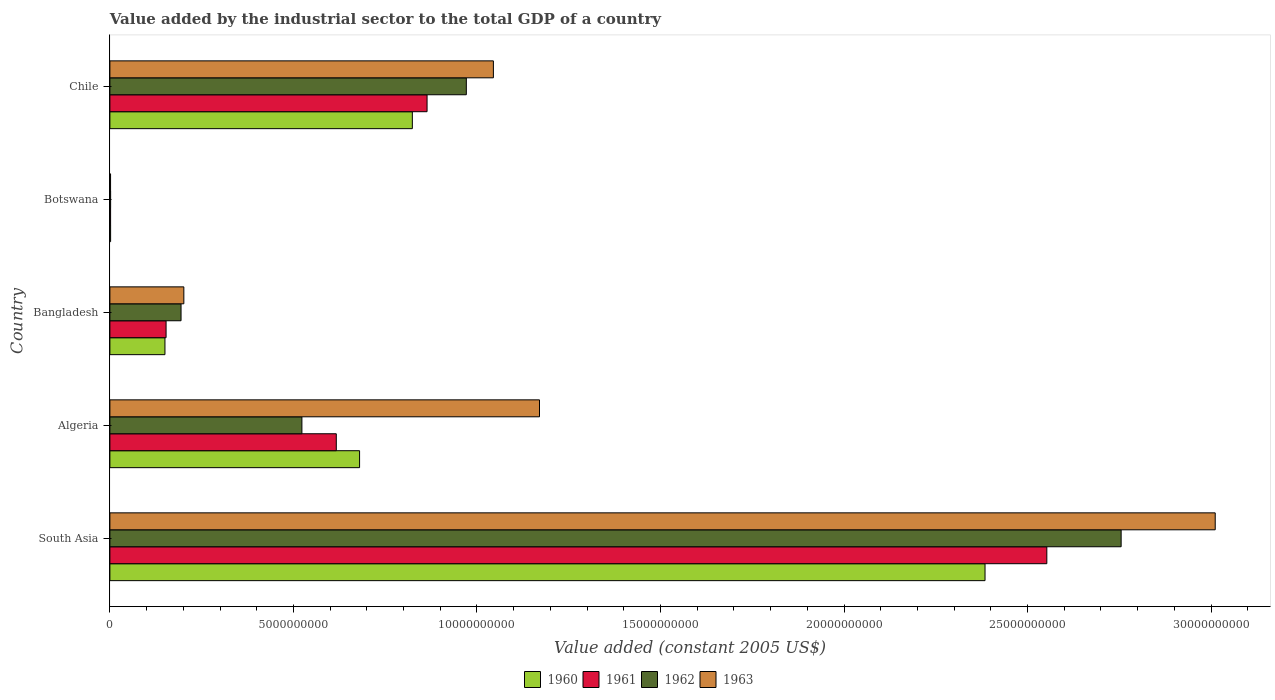How many bars are there on the 1st tick from the bottom?
Offer a terse response. 4. What is the label of the 2nd group of bars from the top?
Offer a very short reply. Botswana. What is the value added by the industrial sector in 1961 in Chile?
Make the answer very short. 8.64e+09. Across all countries, what is the maximum value added by the industrial sector in 1963?
Give a very brief answer. 3.01e+1. Across all countries, what is the minimum value added by the industrial sector in 1961?
Ensure brevity in your answer.  1.92e+07. In which country was the value added by the industrial sector in 1960 minimum?
Your answer should be compact. Botswana. What is the total value added by the industrial sector in 1960 in the graph?
Your answer should be compact. 4.04e+1. What is the difference between the value added by the industrial sector in 1962 in Algeria and that in Botswana?
Your answer should be compact. 5.21e+09. What is the difference between the value added by the industrial sector in 1962 in Chile and the value added by the industrial sector in 1961 in Algeria?
Offer a terse response. 3.54e+09. What is the average value added by the industrial sector in 1963 per country?
Offer a very short reply. 1.09e+1. What is the difference between the value added by the industrial sector in 1961 and value added by the industrial sector in 1963 in Bangladesh?
Give a very brief answer. -4.84e+08. In how many countries, is the value added by the industrial sector in 1963 greater than 1000000000 US$?
Give a very brief answer. 4. What is the ratio of the value added by the industrial sector in 1961 in Algeria to that in Botswana?
Give a very brief answer. 321.41. Is the difference between the value added by the industrial sector in 1961 in Algeria and Bangladesh greater than the difference between the value added by the industrial sector in 1963 in Algeria and Bangladesh?
Your answer should be very brief. No. What is the difference between the highest and the second highest value added by the industrial sector in 1963?
Offer a very short reply. 1.84e+1. What is the difference between the highest and the lowest value added by the industrial sector in 1962?
Make the answer very short. 2.75e+1. Is the sum of the value added by the industrial sector in 1963 in Bangladesh and Chile greater than the maximum value added by the industrial sector in 1961 across all countries?
Provide a short and direct response. No. Is it the case that in every country, the sum of the value added by the industrial sector in 1963 and value added by the industrial sector in 1962 is greater than the sum of value added by the industrial sector in 1961 and value added by the industrial sector in 1960?
Your answer should be compact. No. What does the 4th bar from the top in Botswana represents?
Ensure brevity in your answer.  1960. What does the 2nd bar from the bottom in Botswana represents?
Ensure brevity in your answer.  1961. Are all the bars in the graph horizontal?
Your answer should be very brief. Yes. What is the difference between two consecutive major ticks on the X-axis?
Your answer should be very brief. 5.00e+09. Are the values on the major ticks of X-axis written in scientific E-notation?
Make the answer very short. No. Does the graph contain grids?
Provide a short and direct response. No. How many legend labels are there?
Make the answer very short. 4. What is the title of the graph?
Your answer should be compact. Value added by the industrial sector to the total GDP of a country. Does "1998" appear as one of the legend labels in the graph?
Offer a terse response. No. What is the label or title of the X-axis?
Give a very brief answer. Value added (constant 2005 US$). What is the Value added (constant 2005 US$) in 1960 in South Asia?
Your answer should be very brief. 2.38e+1. What is the Value added (constant 2005 US$) of 1961 in South Asia?
Your response must be concise. 2.55e+1. What is the Value added (constant 2005 US$) of 1962 in South Asia?
Offer a terse response. 2.76e+1. What is the Value added (constant 2005 US$) of 1963 in South Asia?
Give a very brief answer. 3.01e+1. What is the Value added (constant 2005 US$) in 1960 in Algeria?
Provide a short and direct response. 6.80e+09. What is the Value added (constant 2005 US$) in 1961 in Algeria?
Your response must be concise. 6.17e+09. What is the Value added (constant 2005 US$) of 1962 in Algeria?
Ensure brevity in your answer.  5.23e+09. What is the Value added (constant 2005 US$) of 1963 in Algeria?
Your response must be concise. 1.17e+1. What is the Value added (constant 2005 US$) in 1960 in Bangladesh?
Keep it short and to the point. 1.50e+09. What is the Value added (constant 2005 US$) in 1961 in Bangladesh?
Your answer should be compact. 1.53e+09. What is the Value added (constant 2005 US$) of 1962 in Bangladesh?
Ensure brevity in your answer.  1.94e+09. What is the Value added (constant 2005 US$) in 1963 in Bangladesh?
Provide a succinct answer. 2.01e+09. What is the Value added (constant 2005 US$) of 1960 in Botswana?
Provide a short and direct response. 1.96e+07. What is the Value added (constant 2005 US$) of 1961 in Botswana?
Give a very brief answer. 1.92e+07. What is the Value added (constant 2005 US$) in 1962 in Botswana?
Ensure brevity in your answer.  1.98e+07. What is the Value added (constant 2005 US$) of 1963 in Botswana?
Give a very brief answer. 1.83e+07. What is the Value added (constant 2005 US$) of 1960 in Chile?
Keep it short and to the point. 8.24e+09. What is the Value added (constant 2005 US$) in 1961 in Chile?
Give a very brief answer. 8.64e+09. What is the Value added (constant 2005 US$) of 1962 in Chile?
Provide a short and direct response. 9.71e+09. What is the Value added (constant 2005 US$) in 1963 in Chile?
Give a very brief answer. 1.04e+1. Across all countries, what is the maximum Value added (constant 2005 US$) of 1960?
Ensure brevity in your answer.  2.38e+1. Across all countries, what is the maximum Value added (constant 2005 US$) in 1961?
Ensure brevity in your answer.  2.55e+1. Across all countries, what is the maximum Value added (constant 2005 US$) in 1962?
Offer a terse response. 2.76e+1. Across all countries, what is the maximum Value added (constant 2005 US$) of 1963?
Your answer should be compact. 3.01e+1. Across all countries, what is the minimum Value added (constant 2005 US$) of 1960?
Give a very brief answer. 1.96e+07. Across all countries, what is the minimum Value added (constant 2005 US$) of 1961?
Ensure brevity in your answer.  1.92e+07. Across all countries, what is the minimum Value added (constant 2005 US$) in 1962?
Keep it short and to the point. 1.98e+07. Across all countries, what is the minimum Value added (constant 2005 US$) in 1963?
Offer a very short reply. 1.83e+07. What is the total Value added (constant 2005 US$) in 1960 in the graph?
Your response must be concise. 4.04e+1. What is the total Value added (constant 2005 US$) of 1961 in the graph?
Your answer should be very brief. 4.19e+1. What is the total Value added (constant 2005 US$) in 1962 in the graph?
Your answer should be compact. 4.45e+1. What is the total Value added (constant 2005 US$) in 1963 in the graph?
Keep it short and to the point. 5.43e+1. What is the difference between the Value added (constant 2005 US$) in 1960 in South Asia and that in Algeria?
Provide a succinct answer. 1.70e+1. What is the difference between the Value added (constant 2005 US$) in 1961 in South Asia and that in Algeria?
Ensure brevity in your answer.  1.94e+1. What is the difference between the Value added (constant 2005 US$) in 1962 in South Asia and that in Algeria?
Ensure brevity in your answer.  2.23e+1. What is the difference between the Value added (constant 2005 US$) in 1963 in South Asia and that in Algeria?
Your answer should be very brief. 1.84e+1. What is the difference between the Value added (constant 2005 US$) in 1960 in South Asia and that in Bangladesh?
Provide a short and direct response. 2.23e+1. What is the difference between the Value added (constant 2005 US$) in 1961 in South Asia and that in Bangladesh?
Make the answer very short. 2.40e+1. What is the difference between the Value added (constant 2005 US$) of 1962 in South Asia and that in Bangladesh?
Offer a terse response. 2.56e+1. What is the difference between the Value added (constant 2005 US$) of 1963 in South Asia and that in Bangladesh?
Make the answer very short. 2.81e+1. What is the difference between the Value added (constant 2005 US$) of 1960 in South Asia and that in Botswana?
Provide a succinct answer. 2.38e+1. What is the difference between the Value added (constant 2005 US$) of 1961 in South Asia and that in Botswana?
Provide a short and direct response. 2.55e+1. What is the difference between the Value added (constant 2005 US$) of 1962 in South Asia and that in Botswana?
Your answer should be very brief. 2.75e+1. What is the difference between the Value added (constant 2005 US$) of 1963 in South Asia and that in Botswana?
Your answer should be compact. 3.01e+1. What is the difference between the Value added (constant 2005 US$) of 1960 in South Asia and that in Chile?
Offer a terse response. 1.56e+1. What is the difference between the Value added (constant 2005 US$) of 1961 in South Asia and that in Chile?
Offer a very short reply. 1.69e+1. What is the difference between the Value added (constant 2005 US$) in 1962 in South Asia and that in Chile?
Ensure brevity in your answer.  1.78e+1. What is the difference between the Value added (constant 2005 US$) in 1963 in South Asia and that in Chile?
Your response must be concise. 1.97e+1. What is the difference between the Value added (constant 2005 US$) of 1960 in Algeria and that in Bangladesh?
Offer a very short reply. 5.30e+09. What is the difference between the Value added (constant 2005 US$) of 1961 in Algeria and that in Bangladesh?
Your answer should be very brief. 4.64e+09. What is the difference between the Value added (constant 2005 US$) of 1962 in Algeria and that in Bangladesh?
Your response must be concise. 3.29e+09. What is the difference between the Value added (constant 2005 US$) in 1963 in Algeria and that in Bangladesh?
Keep it short and to the point. 9.69e+09. What is the difference between the Value added (constant 2005 US$) in 1960 in Algeria and that in Botswana?
Keep it short and to the point. 6.78e+09. What is the difference between the Value added (constant 2005 US$) in 1961 in Algeria and that in Botswana?
Your response must be concise. 6.15e+09. What is the difference between the Value added (constant 2005 US$) of 1962 in Algeria and that in Botswana?
Make the answer very short. 5.21e+09. What is the difference between the Value added (constant 2005 US$) of 1963 in Algeria and that in Botswana?
Offer a very short reply. 1.17e+1. What is the difference between the Value added (constant 2005 US$) in 1960 in Algeria and that in Chile?
Your answer should be compact. -1.44e+09. What is the difference between the Value added (constant 2005 US$) of 1961 in Algeria and that in Chile?
Your answer should be very brief. -2.47e+09. What is the difference between the Value added (constant 2005 US$) of 1962 in Algeria and that in Chile?
Your response must be concise. -4.48e+09. What is the difference between the Value added (constant 2005 US$) of 1963 in Algeria and that in Chile?
Give a very brief answer. 1.26e+09. What is the difference between the Value added (constant 2005 US$) in 1960 in Bangladesh and that in Botswana?
Give a very brief answer. 1.48e+09. What is the difference between the Value added (constant 2005 US$) of 1961 in Bangladesh and that in Botswana?
Offer a terse response. 1.51e+09. What is the difference between the Value added (constant 2005 US$) in 1962 in Bangladesh and that in Botswana?
Make the answer very short. 1.92e+09. What is the difference between the Value added (constant 2005 US$) of 1963 in Bangladesh and that in Botswana?
Your answer should be very brief. 2.00e+09. What is the difference between the Value added (constant 2005 US$) in 1960 in Bangladesh and that in Chile?
Provide a short and direct response. -6.74e+09. What is the difference between the Value added (constant 2005 US$) in 1961 in Bangladesh and that in Chile?
Your response must be concise. -7.11e+09. What is the difference between the Value added (constant 2005 US$) in 1962 in Bangladesh and that in Chile?
Your answer should be compact. -7.77e+09. What is the difference between the Value added (constant 2005 US$) in 1963 in Bangladesh and that in Chile?
Your answer should be very brief. -8.43e+09. What is the difference between the Value added (constant 2005 US$) of 1960 in Botswana and that in Chile?
Ensure brevity in your answer.  -8.22e+09. What is the difference between the Value added (constant 2005 US$) of 1961 in Botswana and that in Chile?
Your response must be concise. -8.62e+09. What is the difference between the Value added (constant 2005 US$) in 1962 in Botswana and that in Chile?
Make the answer very short. -9.69e+09. What is the difference between the Value added (constant 2005 US$) of 1963 in Botswana and that in Chile?
Offer a very short reply. -1.04e+1. What is the difference between the Value added (constant 2005 US$) in 1960 in South Asia and the Value added (constant 2005 US$) in 1961 in Algeria?
Offer a very short reply. 1.77e+1. What is the difference between the Value added (constant 2005 US$) of 1960 in South Asia and the Value added (constant 2005 US$) of 1962 in Algeria?
Your answer should be compact. 1.86e+1. What is the difference between the Value added (constant 2005 US$) in 1960 in South Asia and the Value added (constant 2005 US$) in 1963 in Algeria?
Your answer should be very brief. 1.21e+1. What is the difference between the Value added (constant 2005 US$) of 1961 in South Asia and the Value added (constant 2005 US$) of 1962 in Algeria?
Keep it short and to the point. 2.03e+1. What is the difference between the Value added (constant 2005 US$) of 1961 in South Asia and the Value added (constant 2005 US$) of 1963 in Algeria?
Keep it short and to the point. 1.38e+1. What is the difference between the Value added (constant 2005 US$) of 1962 in South Asia and the Value added (constant 2005 US$) of 1963 in Algeria?
Provide a short and direct response. 1.58e+1. What is the difference between the Value added (constant 2005 US$) of 1960 in South Asia and the Value added (constant 2005 US$) of 1961 in Bangladesh?
Provide a short and direct response. 2.23e+1. What is the difference between the Value added (constant 2005 US$) of 1960 in South Asia and the Value added (constant 2005 US$) of 1962 in Bangladesh?
Offer a terse response. 2.19e+1. What is the difference between the Value added (constant 2005 US$) of 1960 in South Asia and the Value added (constant 2005 US$) of 1963 in Bangladesh?
Your answer should be very brief. 2.18e+1. What is the difference between the Value added (constant 2005 US$) in 1961 in South Asia and the Value added (constant 2005 US$) in 1962 in Bangladesh?
Provide a succinct answer. 2.36e+1. What is the difference between the Value added (constant 2005 US$) in 1961 in South Asia and the Value added (constant 2005 US$) in 1963 in Bangladesh?
Your answer should be very brief. 2.35e+1. What is the difference between the Value added (constant 2005 US$) of 1962 in South Asia and the Value added (constant 2005 US$) of 1963 in Bangladesh?
Your answer should be compact. 2.55e+1. What is the difference between the Value added (constant 2005 US$) in 1960 in South Asia and the Value added (constant 2005 US$) in 1961 in Botswana?
Keep it short and to the point. 2.38e+1. What is the difference between the Value added (constant 2005 US$) in 1960 in South Asia and the Value added (constant 2005 US$) in 1962 in Botswana?
Keep it short and to the point. 2.38e+1. What is the difference between the Value added (constant 2005 US$) of 1960 in South Asia and the Value added (constant 2005 US$) of 1963 in Botswana?
Give a very brief answer. 2.38e+1. What is the difference between the Value added (constant 2005 US$) in 1961 in South Asia and the Value added (constant 2005 US$) in 1962 in Botswana?
Your answer should be compact. 2.55e+1. What is the difference between the Value added (constant 2005 US$) of 1961 in South Asia and the Value added (constant 2005 US$) of 1963 in Botswana?
Keep it short and to the point. 2.55e+1. What is the difference between the Value added (constant 2005 US$) in 1962 in South Asia and the Value added (constant 2005 US$) in 1963 in Botswana?
Provide a succinct answer. 2.75e+1. What is the difference between the Value added (constant 2005 US$) in 1960 in South Asia and the Value added (constant 2005 US$) in 1961 in Chile?
Your answer should be compact. 1.52e+1. What is the difference between the Value added (constant 2005 US$) of 1960 in South Asia and the Value added (constant 2005 US$) of 1962 in Chile?
Provide a succinct answer. 1.41e+1. What is the difference between the Value added (constant 2005 US$) in 1960 in South Asia and the Value added (constant 2005 US$) in 1963 in Chile?
Offer a terse response. 1.34e+1. What is the difference between the Value added (constant 2005 US$) of 1961 in South Asia and the Value added (constant 2005 US$) of 1962 in Chile?
Your response must be concise. 1.58e+1. What is the difference between the Value added (constant 2005 US$) in 1961 in South Asia and the Value added (constant 2005 US$) in 1963 in Chile?
Your response must be concise. 1.51e+1. What is the difference between the Value added (constant 2005 US$) of 1962 in South Asia and the Value added (constant 2005 US$) of 1963 in Chile?
Ensure brevity in your answer.  1.71e+1. What is the difference between the Value added (constant 2005 US$) in 1960 in Algeria and the Value added (constant 2005 US$) in 1961 in Bangladesh?
Ensure brevity in your answer.  5.27e+09. What is the difference between the Value added (constant 2005 US$) of 1960 in Algeria and the Value added (constant 2005 US$) of 1962 in Bangladesh?
Your answer should be very brief. 4.86e+09. What is the difference between the Value added (constant 2005 US$) in 1960 in Algeria and the Value added (constant 2005 US$) in 1963 in Bangladesh?
Offer a very short reply. 4.79e+09. What is the difference between the Value added (constant 2005 US$) of 1961 in Algeria and the Value added (constant 2005 US$) of 1962 in Bangladesh?
Your answer should be very brief. 4.23e+09. What is the difference between the Value added (constant 2005 US$) of 1961 in Algeria and the Value added (constant 2005 US$) of 1963 in Bangladesh?
Offer a terse response. 4.15e+09. What is the difference between the Value added (constant 2005 US$) of 1962 in Algeria and the Value added (constant 2005 US$) of 1963 in Bangladesh?
Your response must be concise. 3.22e+09. What is the difference between the Value added (constant 2005 US$) in 1960 in Algeria and the Value added (constant 2005 US$) in 1961 in Botswana?
Your answer should be compact. 6.78e+09. What is the difference between the Value added (constant 2005 US$) of 1960 in Algeria and the Value added (constant 2005 US$) of 1962 in Botswana?
Give a very brief answer. 6.78e+09. What is the difference between the Value added (constant 2005 US$) in 1960 in Algeria and the Value added (constant 2005 US$) in 1963 in Botswana?
Ensure brevity in your answer.  6.78e+09. What is the difference between the Value added (constant 2005 US$) of 1961 in Algeria and the Value added (constant 2005 US$) of 1962 in Botswana?
Make the answer very short. 6.15e+09. What is the difference between the Value added (constant 2005 US$) of 1961 in Algeria and the Value added (constant 2005 US$) of 1963 in Botswana?
Offer a terse response. 6.15e+09. What is the difference between the Value added (constant 2005 US$) in 1962 in Algeria and the Value added (constant 2005 US$) in 1963 in Botswana?
Give a very brief answer. 5.21e+09. What is the difference between the Value added (constant 2005 US$) of 1960 in Algeria and the Value added (constant 2005 US$) of 1961 in Chile?
Your answer should be very brief. -1.84e+09. What is the difference between the Value added (constant 2005 US$) in 1960 in Algeria and the Value added (constant 2005 US$) in 1962 in Chile?
Your response must be concise. -2.91e+09. What is the difference between the Value added (constant 2005 US$) in 1960 in Algeria and the Value added (constant 2005 US$) in 1963 in Chile?
Ensure brevity in your answer.  -3.65e+09. What is the difference between the Value added (constant 2005 US$) of 1961 in Algeria and the Value added (constant 2005 US$) of 1962 in Chile?
Provide a short and direct response. -3.54e+09. What is the difference between the Value added (constant 2005 US$) of 1961 in Algeria and the Value added (constant 2005 US$) of 1963 in Chile?
Make the answer very short. -4.28e+09. What is the difference between the Value added (constant 2005 US$) in 1962 in Algeria and the Value added (constant 2005 US$) in 1963 in Chile?
Provide a short and direct response. -5.22e+09. What is the difference between the Value added (constant 2005 US$) in 1960 in Bangladesh and the Value added (constant 2005 US$) in 1961 in Botswana?
Offer a very short reply. 1.48e+09. What is the difference between the Value added (constant 2005 US$) in 1960 in Bangladesh and the Value added (constant 2005 US$) in 1962 in Botswana?
Offer a terse response. 1.48e+09. What is the difference between the Value added (constant 2005 US$) in 1960 in Bangladesh and the Value added (constant 2005 US$) in 1963 in Botswana?
Offer a terse response. 1.48e+09. What is the difference between the Value added (constant 2005 US$) of 1961 in Bangladesh and the Value added (constant 2005 US$) of 1962 in Botswana?
Make the answer very short. 1.51e+09. What is the difference between the Value added (constant 2005 US$) of 1961 in Bangladesh and the Value added (constant 2005 US$) of 1963 in Botswana?
Your answer should be compact. 1.51e+09. What is the difference between the Value added (constant 2005 US$) of 1962 in Bangladesh and the Value added (constant 2005 US$) of 1963 in Botswana?
Your answer should be very brief. 1.92e+09. What is the difference between the Value added (constant 2005 US$) of 1960 in Bangladesh and the Value added (constant 2005 US$) of 1961 in Chile?
Make the answer very short. -7.14e+09. What is the difference between the Value added (constant 2005 US$) of 1960 in Bangladesh and the Value added (constant 2005 US$) of 1962 in Chile?
Your response must be concise. -8.21e+09. What is the difference between the Value added (constant 2005 US$) of 1960 in Bangladesh and the Value added (constant 2005 US$) of 1963 in Chile?
Your answer should be compact. -8.95e+09. What is the difference between the Value added (constant 2005 US$) of 1961 in Bangladesh and the Value added (constant 2005 US$) of 1962 in Chile?
Provide a short and direct response. -8.18e+09. What is the difference between the Value added (constant 2005 US$) of 1961 in Bangladesh and the Value added (constant 2005 US$) of 1963 in Chile?
Keep it short and to the point. -8.92e+09. What is the difference between the Value added (constant 2005 US$) in 1962 in Bangladesh and the Value added (constant 2005 US$) in 1963 in Chile?
Your answer should be compact. -8.51e+09. What is the difference between the Value added (constant 2005 US$) of 1960 in Botswana and the Value added (constant 2005 US$) of 1961 in Chile?
Make the answer very short. -8.62e+09. What is the difference between the Value added (constant 2005 US$) of 1960 in Botswana and the Value added (constant 2005 US$) of 1962 in Chile?
Your response must be concise. -9.69e+09. What is the difference between the Value added (constant 2005 US$) in 1960 in Botswana and the Value added (constant 2005 US$) in 1963 in Chile?
Make the answer very short. -1.04e+1. What is the difference between the Value added (constant 2005 US$) of 1961 in Botswana and the Value added (constant 2005 US$) of 1962 in Chile?
Offer a terse response. -9.69e+09. What is the difference between the Value added (constant 2005 US$) in 1961 in Botswana and the Value added (constant 2005 US$) in 1963 in Chile?
Provide a short and direct response. -1.04e+1. What is the difference between the Value added (constant 2005 US$) in 1962 in Botswana and the Value added (constant 2005 US$) in 1963 in Chile?
Your response must be concise. -1.04e+1. What is the average Value added (constant 2005 US$) of 1960 per country?
Provide a succinct answer. 8.08e+09. What is the average Value added (constant 2005 US$) in 1961 per country?
Ensure brevity in your answer.  8.38e+09. What is the average Value added (constant 2005 US$) in 1962 per country?
Offer a very short reply. 8.89e+09. What is the average Value added (constant 2005 US$) in 1963 per country?
Offer a very short reply. 1.09e+1. What is the difference between the Value added (constant 2005 US$) of 1960 and Value added (constant 2005 US$) of 1961 in South Asia?
Offer a very short reply. -1.68e+09. What is the difference between the Value added (constant 2005 US$) in 1960 and Value added (constant 2005 US$) in 1962 in South Asia?
Provide a succinct answer. -3.71e+09. What is the difference between the Value added (constant 2005 US$) in 1960 and Value added (constant 2005 US$) in 1963 in South Asia?
Keep it short and to the point. -6.27e+09. What is the difference between the Value added (constant 2005 US$) in 1961 and Value added (constant 2005 US$) in 1962 in South Asia?
Your answer should be compact. -2.02e+09. What is the difference between the Value added (constant 2005 US$) in 1961 and Value added (constant 2005 US$) in 1963 in South Asia?
Offer a terse response. -4.59e+09. What is the difference between the Value added (constant 2005 US$) in 1962 and Value added (constant 2005 US$) in 1963 in South Asia?
Ensure brevity in your answer.  -2.56e+09. What is the difference between the Value added (constant 2005 US$) of 1960 and Value added (constant 2005 US$) of 1961 in Algeria?
Give a very brief answer. 6.34e+08. What is the difference between the Value added (constant 2005 US$) of 1960 and Value added (constant 2005 US$) of 1962 in Algeria?
Provide a succinct answer. 1.57e+09. What is the difference between the Value added (constant 2005 US$) of 1960 and Value added (constant 2005 US$) of 1963 in Algeria?
Your response must be concise. -4.90e+09. What is the difference between the Value added (constant 2005 US$) in 1961 and Value added (constant 2005 US$) in 1962 in Algeria?
Offer a terse response. 9.37e+08. What is the difference between the Value added (constant 2005 US$) of 1961 and Value added (constant 2005 US$) of 1963 in Algeria?
Offer a terse response. -5.54e+09. What is the difference between the Value added (constant 2005 US$) of 1962 and Value added (constant 2005 US$) of 1963 in Algeria?
Your response must be concise. -6.47e+09. What is the difference between the Value added (constant 2005 US$) of 1960 and Value added (constant 2005 US$) of 1961 in Bangladesh?
Your answer should be very brief. -3.05e+07. What is the difference between the Value added (constant 2005 US$) in 1960 and Value added (constant 2005 US$) in 1962 in Bangladesh?
Make the answer very short. -4.38e+08. What is the difference between the Value added (constant 2005 US$) of 1960 and Value added (constant 2005 US$) of 1963 in Bangladesh?
Your answer should be compact. -5.14e+08. What is the difference between the Value added (constant 2005 US$) of 1961 and Value added (constant 2005 US$) of 1962 in Bangladesh?
Ensure brevity in your answer.  -4.08e+08. What is the difference between the Value added (constant 2005 US$) of 1961 and Value added (constant 2005 US$) of 1963 in Bangladesh?
Your response must be concise. -4.84e+08. What is the difference between the Value added (constant 2005 US$) in 1962 and Value added (constant 2005 US$) in 1963 in Bangladesh?
Your response must be concise. -7.60e+07. What is the difference between the Value added (constant 2005 US$) of 1960 and Value added (constant 2005 US$) of 1961 in Botswana?
Give a very brief answer. 4.24e+05. What is the difference between the Value added (constant 2005 US$) of 1960 and Value added (constant 2005 US$) of 1962 in Botswana?
Your answer should be very brief. -2.12e+05. What is the difference between the Value added (constant 2005 US$) in 1960 and Value added (constant 2005 US$) in 1963 in Botswana?
Your answer should be compact. 1.27e+06. What is the difference between the Value added (constant 2005 US$) of 1961 and Value added (constant 2005 US$) of 1962 in Botswana?
Offer a very short reply. -6.36e+05. What is the difference between the Value added (constant 2005 US$) in 1961 and Value added (constant 2005 US$) in 1963 in Botswana?
Your response must be concise. 8.48e+05. What is the difference between the Value added (constant 2005 US$) of 1962 and Value added (constant 2005 US$) of 1963 in Botswana?
Keep it short and to the point. 1.48e+06. What is the difference between the Value added (constant 2005 US$) of 1960 and Value added (constant 2005 US$) of 1961 in Chile?
Provide a succinct answer. -4.01e+08. What is the difference between the Value added (constant 2005 US$) in 1960 and Value added (constant 2005 US$) in 1962 in Chile?
Your response must be concise. -1.47e+09. What is the difference between the Value added (constant 2005 US$) in 1960 and Value added (constant 2005 US$) in 1963 in Chile?
Offer a very short reply. -2.21e+09. What is the difference between the Value added (constant 2005 US$) in 1961 and Value added (constant 2005 US$) in 1962 in Chile?
Provide a succinct answer. -1.07e+09. What is the difference between the Value added (constant 2005 US$) in 1961 and Value added (constant 2005 US$) in 1963 in Chile?
Your response must be concise. -1.81e+09. What is the difference between the Value added (constant 2005 US$) in 1962 and Value added (constant 2005 US$) in 1963 in Chile?
Offer a terse response. -7.37e+08. What is the ratio of the Value added (constant 2005 US$) in 1960 in South Asia to that in Algeria?
Provide a succinct answer. 3.5. What is the ratio of the Value added (constant 2005 US$) in 1961 in South Asia to that in Algeria?
Your response must be concise. 4.14. What is the ratio of the Value added (constant 2005 US$) of 1962 in South Asia to that in Algeria?
Give a very brief answer. 5.27. What is the ratio of the Value added (constant 2005 US$) in 1963 in South Asia to that in Algeria?
Make the answer very short. 2.57. What is the ratio of the Value added (constant 2005 US$) in 1960 in South Asia to that in Bangladesh?
Your answer should be very brief. 15.89. What is the ratio of the Value added (constant 2005 US$) in 1961 in South Asia to that in Bangladesh?
Provide a short and direct response. 16.68. What is the ratio of the Value added (constant 2005 US$) in 1962 in South Asia to that in Bangladesh?
Give a very brief answer. 14.21. What is the ratio of the Value added (constant 2005 US$) in 1963 in South Asia to that in Bangladesh?
Your answer should be compact. 14.95. What is the ratio of the Value added (constant 2005 US$) in 1960 in South Asia to that in Botswana?
Offer a terse response. 1215.49. What is the ratio of the Value added (constant 2005 US$) of 1961 in South Asia to that in Botswana?
Keep it short and to the point. 1330.08. What is the ratio of the Value added (constant 2005 US$) of 1962 in South Asia to that in Botswana?
Keep it short and to the point. 1389.51. What is the ratio of the Value added (constant 2005 US$) of 1963 in South Asia to that in Botswana?
Provide a succinct answer. 1641.69. What is the ratio of the Value added (constant 2005 US$) of 1960 in South Asia to that in Chile?
Your answer should be very brief. 2.89. What is the ratio of the Value added (constant 2005 US$) in 1961 in South Asia to that in Chile?
Offer a terse response. 2.95. What is the ratio of the Value added (constant 2005 US$) of 1962 in South Asia to that in Chile?
Your response must be concise. 2.84. What is the ratio of the Value added (constant 2005 US$) in 1963 in South Asia to that in Chile?
Your answer should be compact. 2.88. What is the ratio of the Value added (constant 2005 US$) in 1960 in Algeria to that in Bangladesh?
Keep it short and to the point. 4.53. What is the ratio of the Value added (constant 2005 US$) in 1961 in Algeria to that in Bangladesh?
Ensure brevity in your answer.  4.03. What is the ratio of the Value added (constant 2005 US$) in 1962 in Algeria to that in Bangladesh?
Your response must be concise. 2.7. What is the ratio of the Value added (constant 2005 US$) in 1963 in Algeria to that in Bangladesh?
Your response must be concise. 5.81. What is the ratio of the Value added (constant 2005 US$) in 1960 in Algeria to that in Botswana?
Your response must be concise. 346.79. What is the ratio of the Value added (constant 2005 US$) of 1961 in Algeria to that in Botswana?
Provide a succinct answer. 321.41. What is the ratio of the Value added (constant 2005 US$) in 1962 in Algeria to that in Botswana?
Provide a succinct answer. 263.85. What is the ratio of the Value added (constant 2005 US$) of 1963 in Algeria to that in Botswana?
Make the answer very short. 638.08. What is the ratio of the Value added (constant 2005 US$) in 1960 in Algeria to that in Chile?
Your response must be concise. 0.83. What is the ratio of the Value added (constant 2005 US$) of 1961 in Algeria to that in Chile?
Provide a succinct answer. 0.71. What is the ratio of the Value added (constant 2005 US$) in 1962 in Algeria to that in Chile?
Your answer should be very brief. 0.54. What is the ratio of the Value added (constant 2005 US$) of 1963 in Algeria to that in Chile?
Your answer should be compact. 1.12. What is the ratio of the Value added (constant 2005 US$) in 1960 in Bangladesh to that in Botswana?
Make the answer very short. 76.48. What is the ratio of the Value added (constant 2005 US$) of 1961 in Bangladesh to that in Botswana?
Make the answer very short. 79.76. What is the ratio of the Value added (constant 2005 US$) of 1962 in Bangladesh to that in Botswana?
Give a very brief answer. 97.78. What is the ratio of the Value added (constant 2005 US$) in 1963 in Bangladesh to that in Botswana?
Keep it short and to the point. 109.83. What is the ratio of the Value added (constant 2005 US$) of 1960 in Bangladesh to that in Chile?
Give a very brief answer. 0.18. What is the ratio of the Value added (constant 2005 US$) of 1961 in Bangladesh to that in Chile?
Offer a terse response. 0.18. What is the ratio of the Value added (constant 2005 US$) in 1962 in Bangladesh to that in Chile?
Offer a terse response. 0.2. What is the ratio of the Value added (constant 2005 US$) of 1963 in Bangladesh to that in Chile?
Offer a terse response. 0.19. What is the ratio of the Value added (constant 2005 US$) in 1960 in Botswana to that in Chile?
Make the answer very short. 0. What is the ratio of the Value added (constant 2005 US$) in 1961 in Botswana to that in Chile?
Keep it short and to the point. 0. What is the ratio of the Value added (constant 2005 US$) of 1962 in Botswana to that in Chile?
Keep it short and to the point. 0. What is the ratio of the Value added (constant 2005 US$) in 1963 in Botswana to that in Chile?
Provide a succinct answer. 0. What is the difference between the highest and the second highest Value added (constant 2005 US$) of 1960?
Ensure brevity in your answer.  1.56e+1. What is the difference between the highest and the second highest Value added (constant 2005 US$) in 1961?
Offer a terse response. 1.69e+1. What is the difference between the highest and the second highest Value added (constant 2005 US$) of 1962?
Keep it short and to the point. 1.78e+1. What is the difference between the highest and the second highest Value added (constant 2005 US$) in 1963?
Make the answer very short. 1.84e+1. What is the difference between the highest and the lowest Value added (constant 2005 US$) of 1960?
Offer a very short reply. 2.38e+1. What is the difference between the highest and the lowest Value added (constant 2005 US$) of 1961?
Offer a terse response. 2.55e+1. What is the difference between the highest and the lowest Value added (constant 2005 US$) of 1962?
Your answer should be compact. 2.75e+1. What is the difference between the highest and the lowest Value added (constant 2005 US$) in 1963?
Make the answer very short. 3.01e+1. 